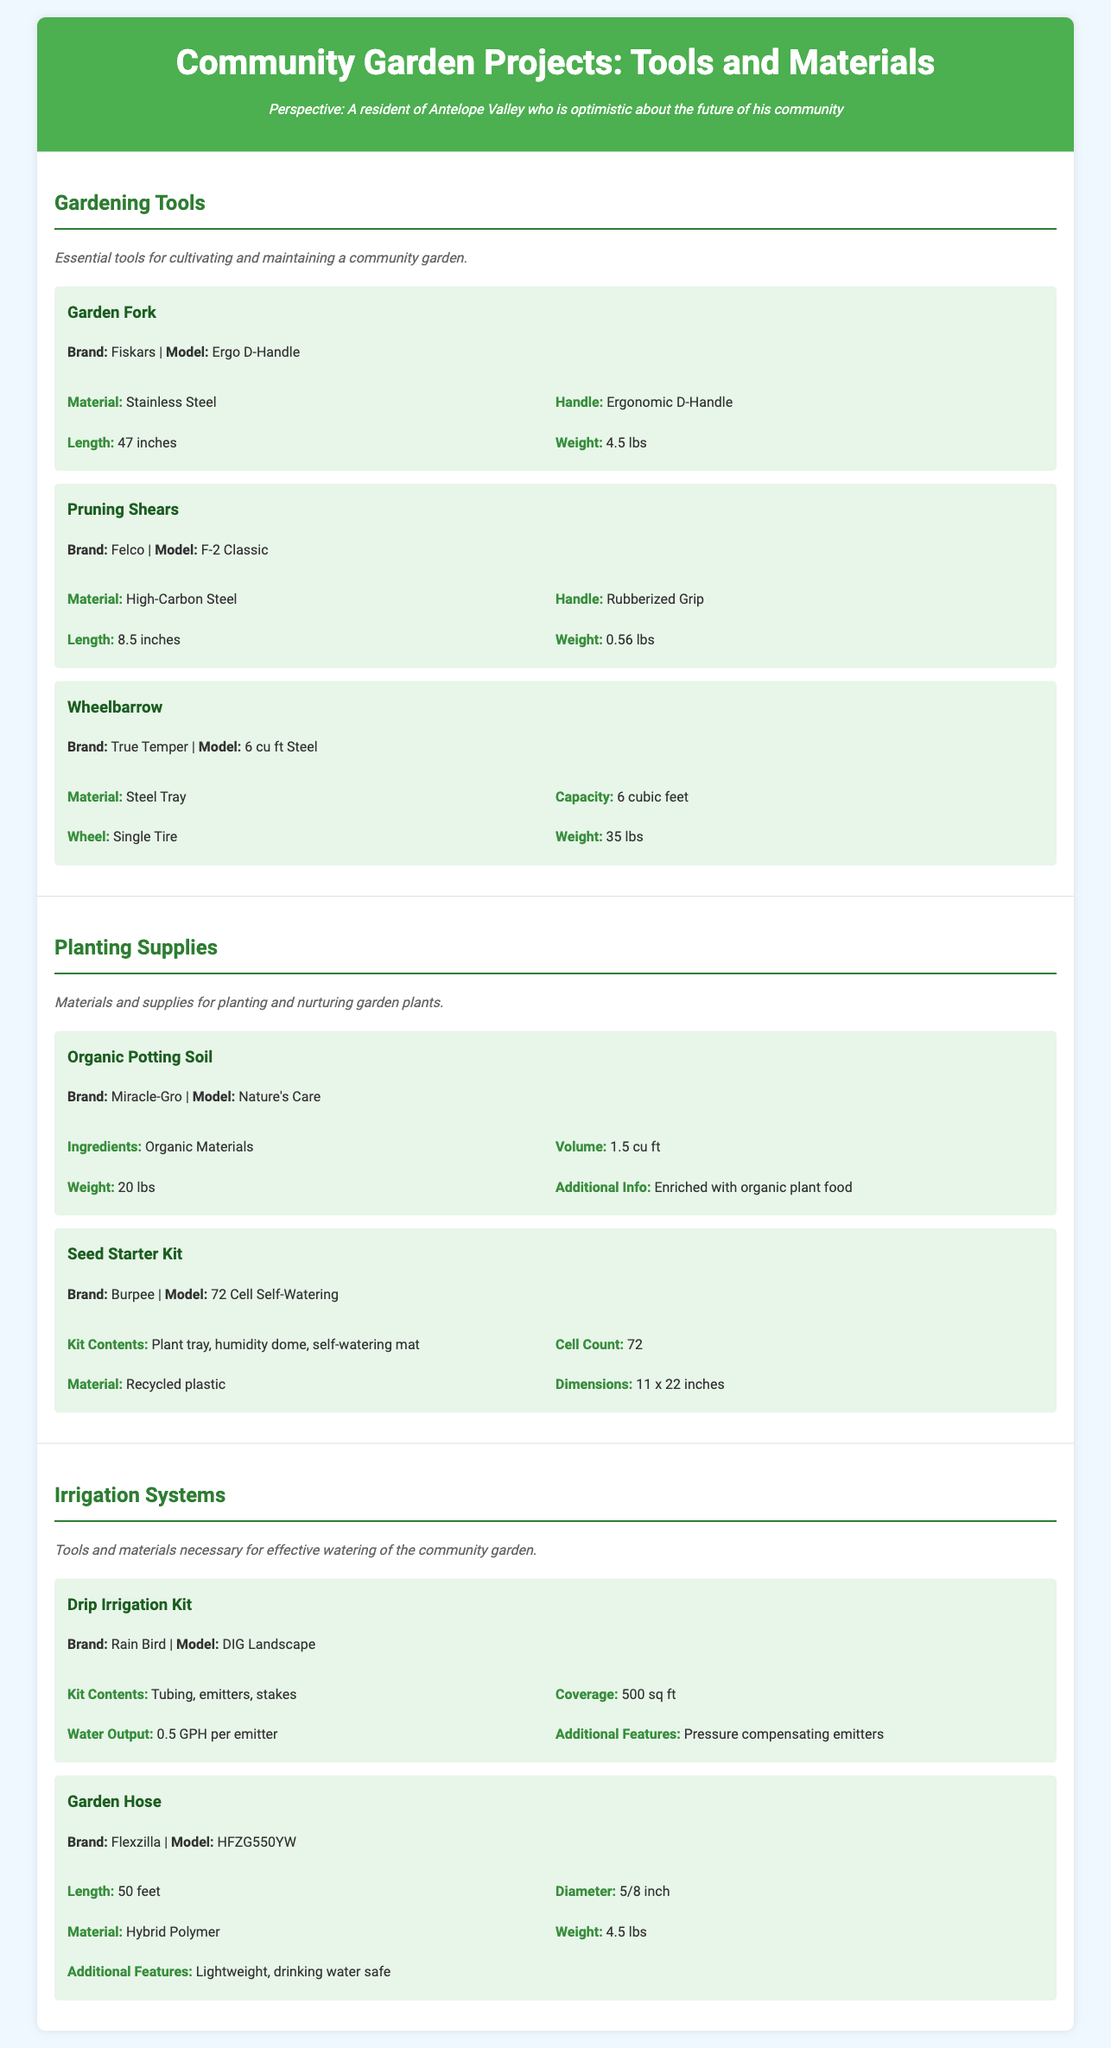What is the brand of the Garden Fork? The brand of the Garden Fork is stated in the specifications section of the document.
Answer: Fiskars What is the weight of the Pruning Shears? The weight of the Pruning Shears is provided in the specifications of that item.
Answer: 0.56 lbs How many cubic feet is the Wheelbarrow's capacity? The capacity of the Wheelbarrow is detailed under its specifications in the document.
Answer: 6 cubic feet What materials are included in the Organic Potting Soil? The ingredients of the Organic Potting Soil are given in its specifications section.
Answer: Organic Materials What additional feature does the Drip Irrigation Kit have? The additional features of the Drip Irrigation Kit are specified in the document.
Answer: Pressure compensating emitters What is the material of the Garden Hose? The material of the Garden Hose is found in its specifications listing.
Answer: Hybrid Polymer How many cells does the Seed Starter Kit contain? The number of cells in the Seed Starter Kit is indicated in the item's specification.
Answer: 72 What is the handle type of the Garden Fork? The handle type of the Garden Fork is noted in the specifications section.
Answer: Ergonomic D-Handle What is the dimension of the Seed Starter Kit? The dimensions of the Seed Starter Kit are listed in its specifications section.
Answer: 11 x 22 inches 